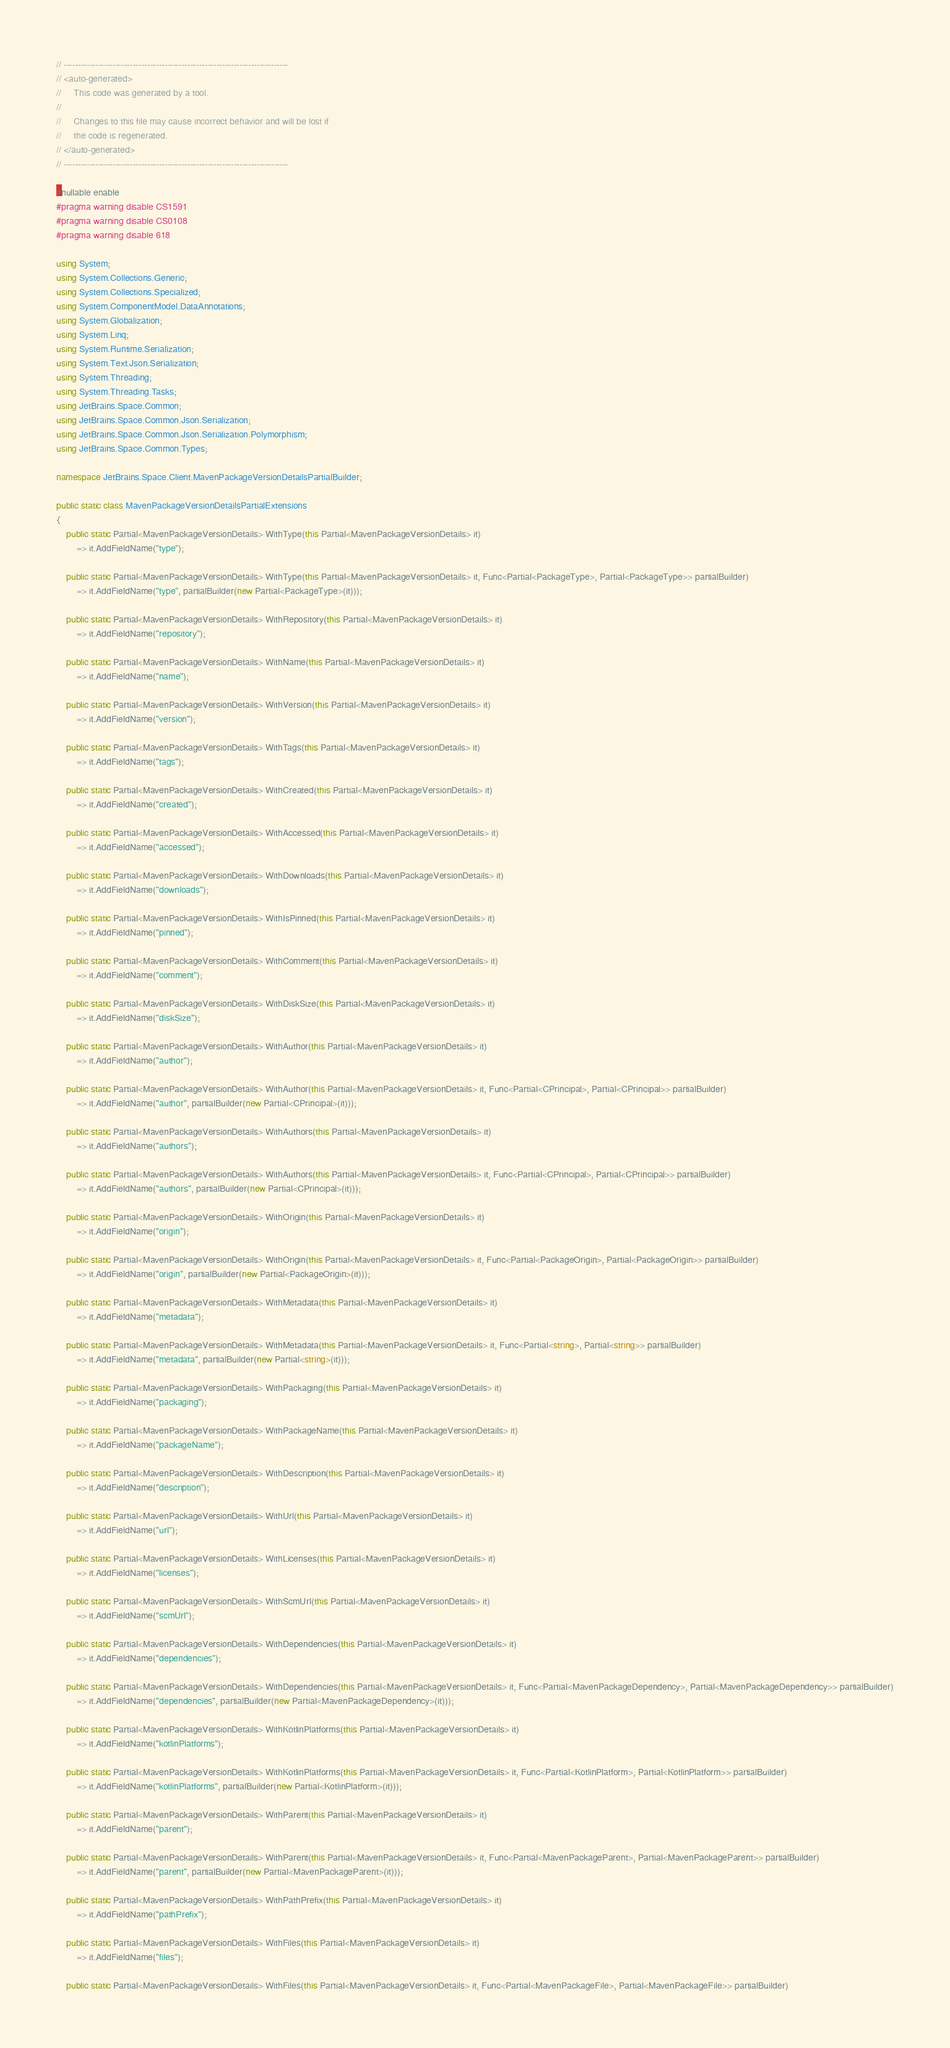<code> <loc_0><loc_0><loc_500><loc_500><_C#_>// ------------------------------------------------------------------------------
// <auto-generated>
//     This code was generated by a tool.
// 
//     Changes to this file may cause incorrect behavior and will be lost if
//     the code is regenerated.
// </auto-generated>
// ------------------------------------------------------------------------------

#nullable enable
#pragma warning disable CS1591
#pragma warning disable CS0108
#pragma warning disable 618

using System;
using System.Collections.Generic;
using System.Collections.Specialized;
using System.ComponentModel.DataAnnotations;
using System.Globalization;
using System.Linq;
using System.Runtime.Serialization;
using System.Text.Json.Serialization;
using System.Threading;
using System.Threading.Tasks;
using JetBrains.Space.Common;
using JetBrains.Space.Common.Json.Serialization;
using JetBrains.Space.Common.Json.Serialization.Polymorphism;
using JetBrains.Space.Common.Types;

namespace JetBrains.Space.Client.MavenPackageVersionDetailsPartialBuilder;

public static class MavenPackageVersionDetailsPartialExtensions
{
    public static Partial<MavenPackageVersionDetails> WithType(this Partial<MavenPackageVersionDetails> it)
        => it.AddFieldName("type");
    
    public static Partial<MavenPackageVersionDetails> WithType(this Partial<MavenPackageVersionDetails> it, Func<Partial<PackageType>, Partial<PackageType>> partialBuilder)
        => it.AddFieldName("type", partialBuilder(new Partial<PackageType>(it)));
    
    public static Partial<MavenPackageVersionDetails> WithRepository(this Partial<MavenPackageVersionDetails> it)
        => it.AddFieldName("repository");
    
    public static Partial<MavenPackageVersionDetails> WithName(this Partial<MavenPackageVersionDetails> it)
        => it.AddFieldName("name");
    
    public static Partial<MavenPackageVersionDetails> WithVersion(this Partial<MavenPackageVersionDetails> it)
        => it.AddFieldName("version");
    
    public static Partial<MavenPackageVersionDetails> WithTags(this Partial<MavenPackageVersionDetails> it)
        => it.AddFieldName("tags");
    
    public static Partial<MavenPackageVersionDetails> WithCreated(this Partial<MavenPackageVersionDetails> it)
        => it.AddFieldName("created");
    
    public static Partial<MavenPackageVersionDetails> WithAccessed(this Partial<MavenPackageVersionDetails> it)
        => it.AddFieldName("accessed");
    
    public static Partial<MavenPackageVersionDetails> WithDownloads(this Partial<MavenPackageVersionDetails> it)
        => it.AddFieldName("downloads");
    
    public static Partial<MavenPackageVersionDetails> WithIsPinned(this Partial<MavenPackageVersionDetails> it)
        => it.AddFieldName("pinned");
    
    public static Partial<MavenPackageVersionDetails> WithComment(this Partial<MavenPackageVersionDetails> it)
        => it.AddFieldName("comment");
    
    public static Partial<MavenPackageVersionDetails> WithDiskSize(this Partial<MavenPackageVersionDetails> it)
        => it.AddFieldName("diskSize");
    
    public static Partial<MavenPackageVersionDetails> WithAuthor(this Partial<MavenPackageVersionDetails> it)
        => it.AddFieldName("author");
    
    public static Partial<MavenPackageVersionDetails> WithAuthor(this Partial<MavenPackageVersionDetails> it, Func<Partial<CPrincipal>, Partial<CPrincipal>> partialBuilder)
        => it.AddFieldName("author", partialBuilder(new Partial<CPrincipal>(it)));
    
    public static Partial<MavenPackageVersionDetails> WithAuthors(this Partial<MavenPackageVersionDetails> it)
        => it.AddFieldName("authors");
    
    public static Partial<MavenPackageVersionDetails> WithAuthors(this Partial<MavenPackageVersionDetails> it, Func<Partial<CPrincipal>, Partial<CPrincipal>> partialBuilder)
        => it.AddFieldName("authors", partialBuilder(new Partial<CPrincipal>(it)));
    
    public static Partial<MavenPackageVersionDetails> WithOrigin(this Partial<MavenPackageVersionDetails> it)
        => it.AddFieldName("origin");
    
    public static Partial<MavenPackageVersionDetails> WithOrigin(this Partial<MavenPackageVersionDetails> it, Func<Partial<PackageOrigin>, Partial<PackageOrigin>> partialBuilder)
        => it.AddFieldName("origin", partialBuilder(new Partial<PackageOrigin>(it)));
    
    public static Partial<MavenPackageVersionDetails> WithMetadata(this Partial<MavenPackageVersionDetails> it)
        => it.AddFieldName("metadata");
    
    public static Partial<MavenPackageVersionDetails> WithMetadata(this Partial<MavenPackageVersionDetails> it, Func<Partial<string>, Partial<string>> partialBuilder)
        => it.AddFieldName("metadata", partialBuilder(new Partial<string>(it)));
    
    public static Partial<MavenPackageVersionDetails> WithPackaging(this Partial<MavenPackageVersionDetails> it)
        => it.AddFieldName("packaging");
    
    public static Partial<MavenPackageVersionDetails> WithPackageName(this Partial<MavenPackageVersionDetails> it)
        => it.AddFieldName("packageName");
    
    public static Partial<MavenPackageVersionDetails> WithDescription(this Partial<MavenPackageVersionDetails> it)
        => it.AddFieldName("description");
    
    public static Partial<MavenPackageVersionDetails> WithUrl(this Partial<MavenPackageVersionDetails> it)
        => it.AddFieldName("url");
    
    public static Partial<MavenPackageVersionDetails> WithLicenses(this Partial<MavenPackageVersionDetails> it)
        => it.AddFieldName("licenses");
    
    public static Partial<MavenPackageVersionDetails> WithScmUrl(this Partial<MavenPackageVersionDetails> it)
        => it.AddFieldName("scmUrl");
    
    public static Partial<MavenPackageVersionDetails> WithDependencies(this Partial<MavenPackageVersionDetails> it)
        => it.AddFieldName("dependencies");
    
    public static Partial<MavenPackageVersionDetails> WithDependencies(this Partial<MavenPackageVersionDetails> it, Func<Partial<MavenPackageDependency>, Partial<MavenPackageDependency>> partialBuilder)
        => it.AddFieldName("dependencies", partialBuilder(new Partial<MavenPackageDependency>(it)));
    
    public static Partial<MavenPackageVersionDetails> WithKotlinPlatforms(this Partial<MavenPackageVersionDetails> it)
        => it.AddFieldName("kotlinPlatforms");
    
    public static Partial<MavenPackageVersionDetails> WithKotlinPlatforms(this Partial<MavenPackageVersionDetails> it, Func<Partial<KotlinPlatform>, Partial<KotlinPlatform>> partialBuilder)
        => it.AddFieldName("kotlinPlatforms", partialBuilder(new Partial<KotlinPlatform>(it)));
    
    public static Partial<MavenPackageVersionDetails> WithParent(this Partial<MavenPackageVersionDetails> it)
        => it.AddFieldName("parent");
    
    public static Partial<MavenPackageVersionDetails> WithParent(this Partial<MavenPackageVersionDetails> it, Func<Partial<MavenPackageParent>, Partial<MavenPackageParent>> partialBuilder)
        => it.AddFieldName("parent", partialBuilder(new Partial<MavenPackageParent>(it)));
    
    public static Partial<MavenPackageVersionDetails> WithPathPrefix(this Partial<MavenPackageVersionDetails> it)
        => it.AddFieldName("pathPrefix");
    
    public static Partial<MavenPackageVersionDetails> WithFiles(this Partial<MavenPackageVersionDetails> it)
        => it.AddFieldName("files");
    
    public static Partial<MavenPackageVersionDetails> WithFiles(this Partial<MavenPackageVersionDetails> it, Func<Partial<MavenPackageFile>, Partial<MavenPackageFile>> partialBuilder)</code> 